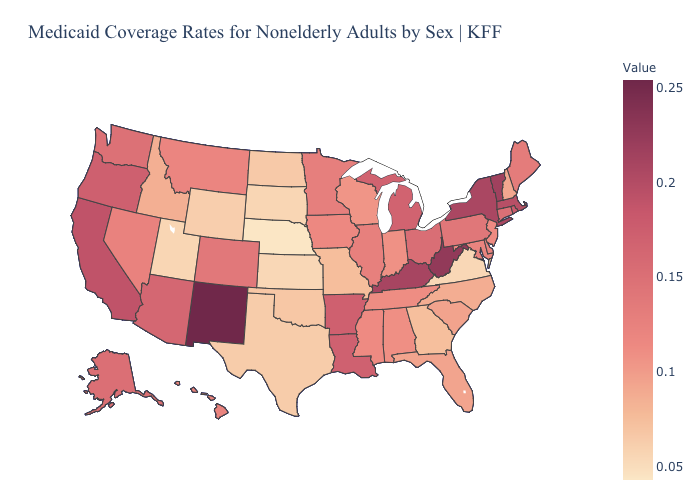Does New York have the highest value in the USA?
Give a very brief answer. No. Among the states that border Oregon , does California have the highest value?
Keep it brief. Yes. Does Utah have the lowest value in the West?
Write a very short answer. Yes. 